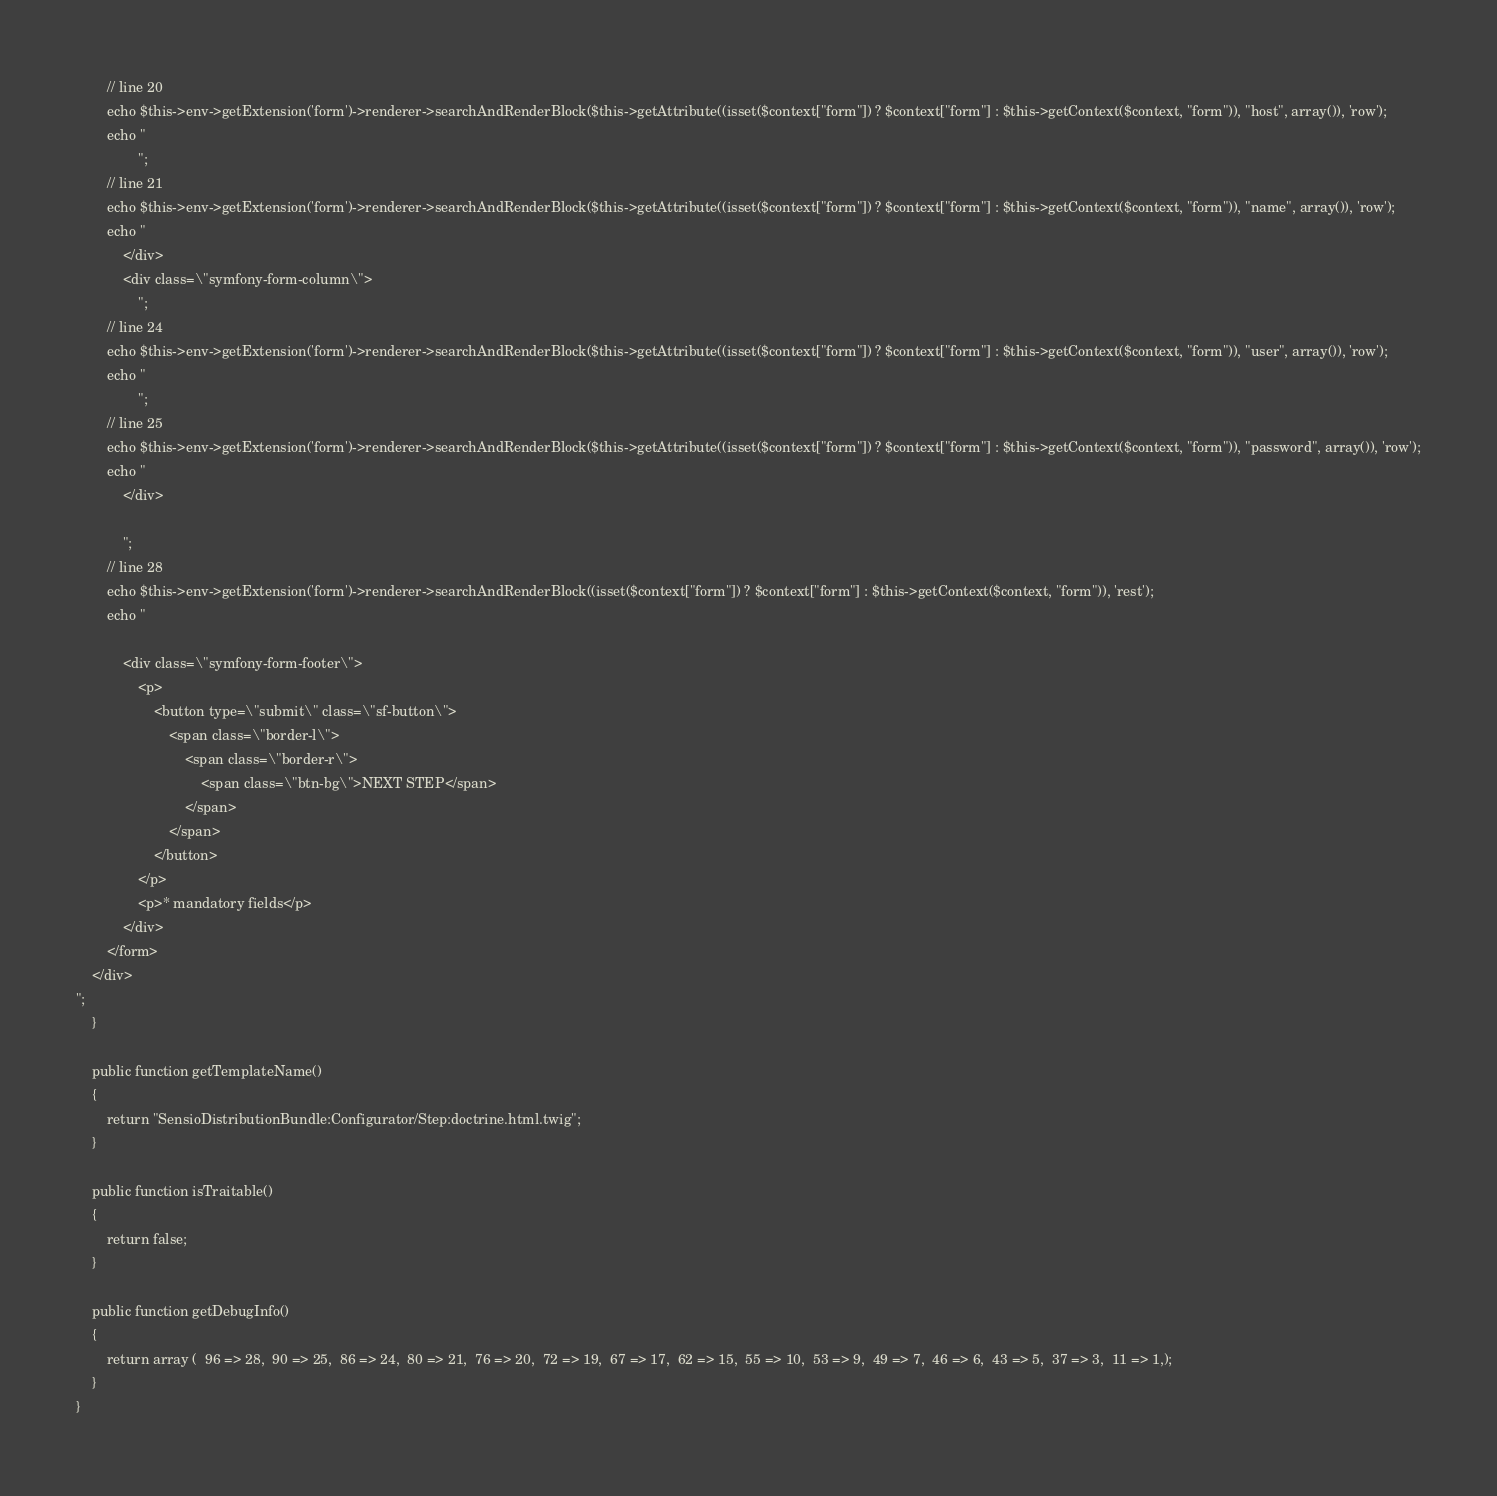<code> <loc_0><loc_0><loc_500><loc_500><_PHP_>        // line 20
        echo $this->env->getExtension('form')->renderer->searchAndRenderBlock($this->getAttribute((isset($context["form"]) ? $context["form"] : $this->getContext($context, "form")), "host", array()), 'row');
        echo "
                ";
        // line 21
        echo $this->env->getExtension('form')->renderer->searchAndRenderBlock($this->getAttribute((isset($context["form"]) ? $context["form"] : $this->getContext($context, "form")), "name", array()), 'row');
        echo "
            </div>
            <div class=\"symfony-form-column\">
                ";
        // line 24
        echo $this->env->getExtension('form')->renderer->searchAndRenderBlock($this->getAttribute((isset($context["form"]) ? $context["form"] : $this->getContext($context, "form")), "user", array()), 'row');
        echo "
                ";
        // line 25
        echo $this->env->getExtension('form')->renderer->searchAndRenderBlock($this->getAttribute((isset($context["form"]) ? $context["form"] : $this->getContext($context, "form")), "password", array()), 'row');
        echo "
            </div>

            ";
        // line 28
        echo $this->env->getExtension('form')->renderer->searchAndRenderBlock((isset($context["form"]) ? $context["form"] : $this->getContext($context, "form")), 'rest');
        echo "

            <div class=\"symfony-form-footer\">
                <p>
                    <button type=\"submit\" class=\"sf-button\">
                        <span class=\"border-l\">
                            <span class=\"border-r\">
                                <span class=\"btn-bg\">NEXT STEP</span>
                            </span>
                        </span>
                    </button>
                </p>
                <p>* mandatory fields</p>
            </div>
        </form>
    </div>
";
    }

    public function getTemplateName()
    {
        return "SensioDistributionBundle:Configurator/Step:doctrine.html.twig";
    }

    public function isTraitable()
    {
        return false;
    }

    public function getDebugInfo()
    {
        return array (  96 => 28,  90 => 25,  86 => 24,  80 => 21,  76 => 20,  72 => 19,  67 => 17,  62 => 15,  55 => 10,  53 => 9,  49 => 7,  46 => 6,  43 => 5,  37 => 3,  11 => 1,);
    }
}
</code> 